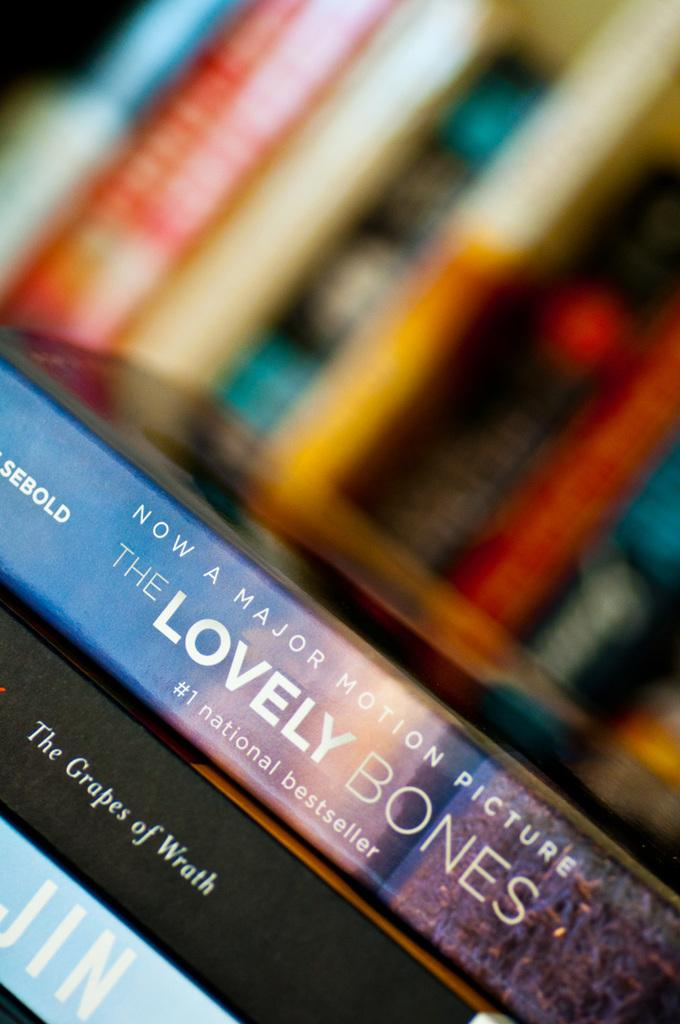<image>
Write a terse but informative summary of the picture. A stack of books including The Graps of Wrath and The Lovely Bones. 